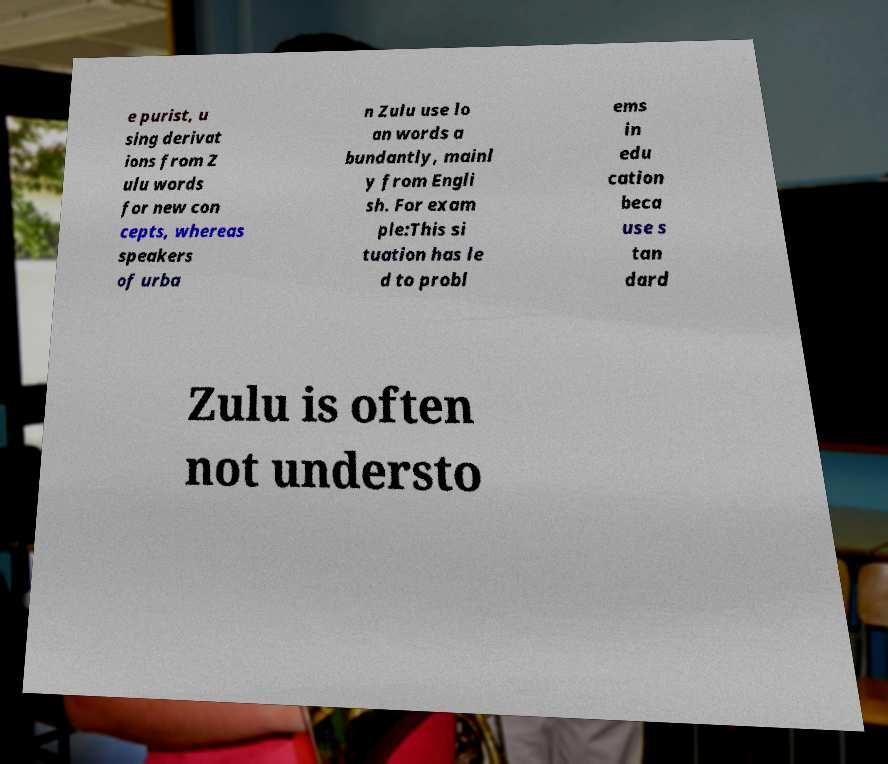What messages or text are displayed in this image? I need them in a readable, typed format. e purist, u sing derivat ions from Z ulu words for new con cepts, whereas speakers of urba n Zulu use lo an words a bundantly, mainl y from Engli sh. For exam ple:This si tuation has le d to probl ems in edu cation beca use s tan dard Zulu is often not understo 